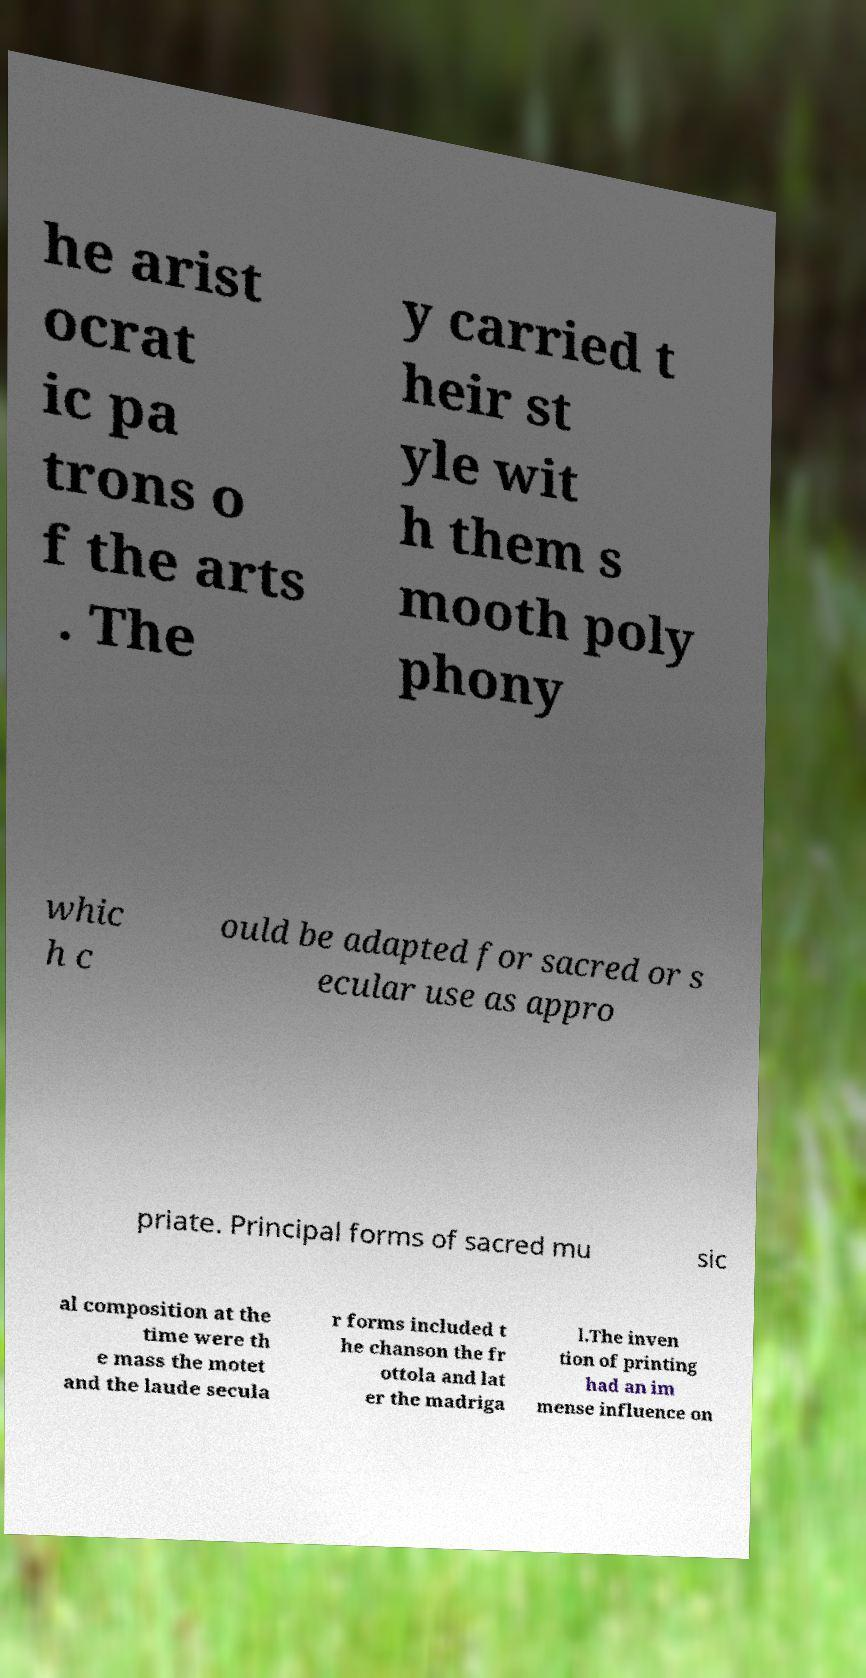For documentation purposes, I need the text within this image transcribed. Could you provide that? he arist ocrat ic pa trons o f the arts . The y carried t heir st yle wit h them s mooth poly phony whic h c ould be adapted for sacred or s ecular use as appro priate. Principal forms of sacred mu sic al composition at the time were th e mass the motet and the laude secula r forms included t he chanson the fr ottola and lat er the madriga l.The inven tion of printing had an im mense influence on 